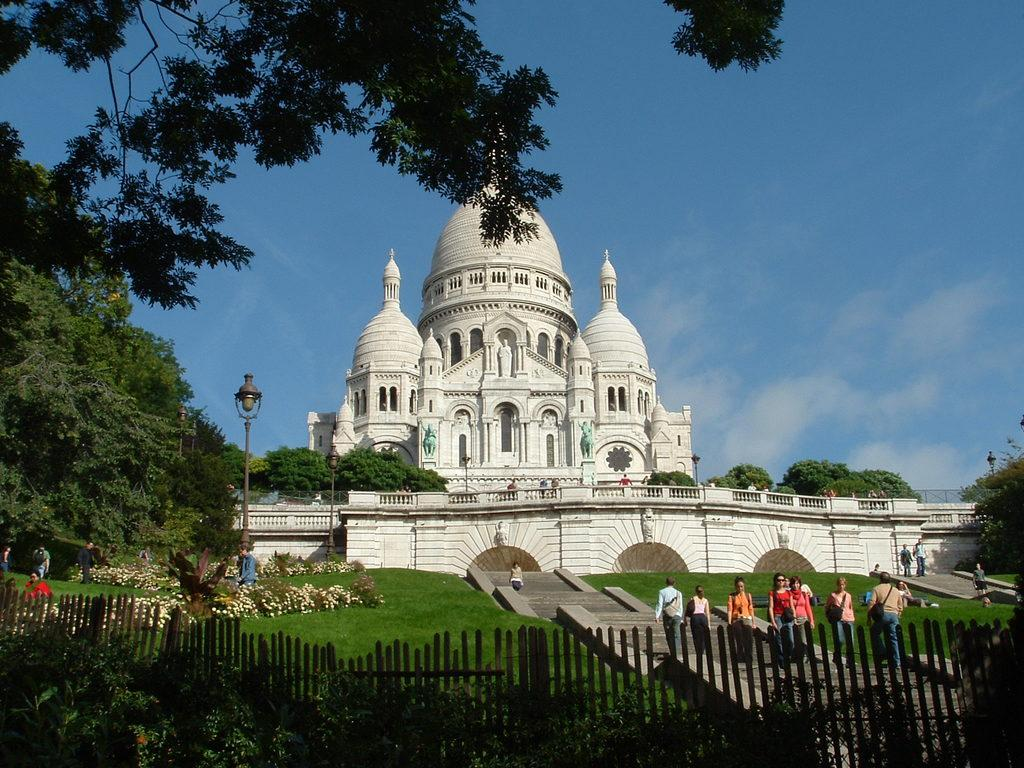What type of vegetation can be seen in the image? There are plants, grass, and trees in the image. What type of structure is present in the image? There is a white building in the image. What is the purpose of the fencing in the image? The fencing in the image serves as a barrier or boundary. What can be seen in the background of the image? There are trees in the background of the image. How many people are present in the image? There are people in the image. What other objects can be seen in the image? There are poles in the image. What type of slope can be seen in the image? There is no slope present in the image. What kind of party is happening in the image? There is no party depicted in the image. 